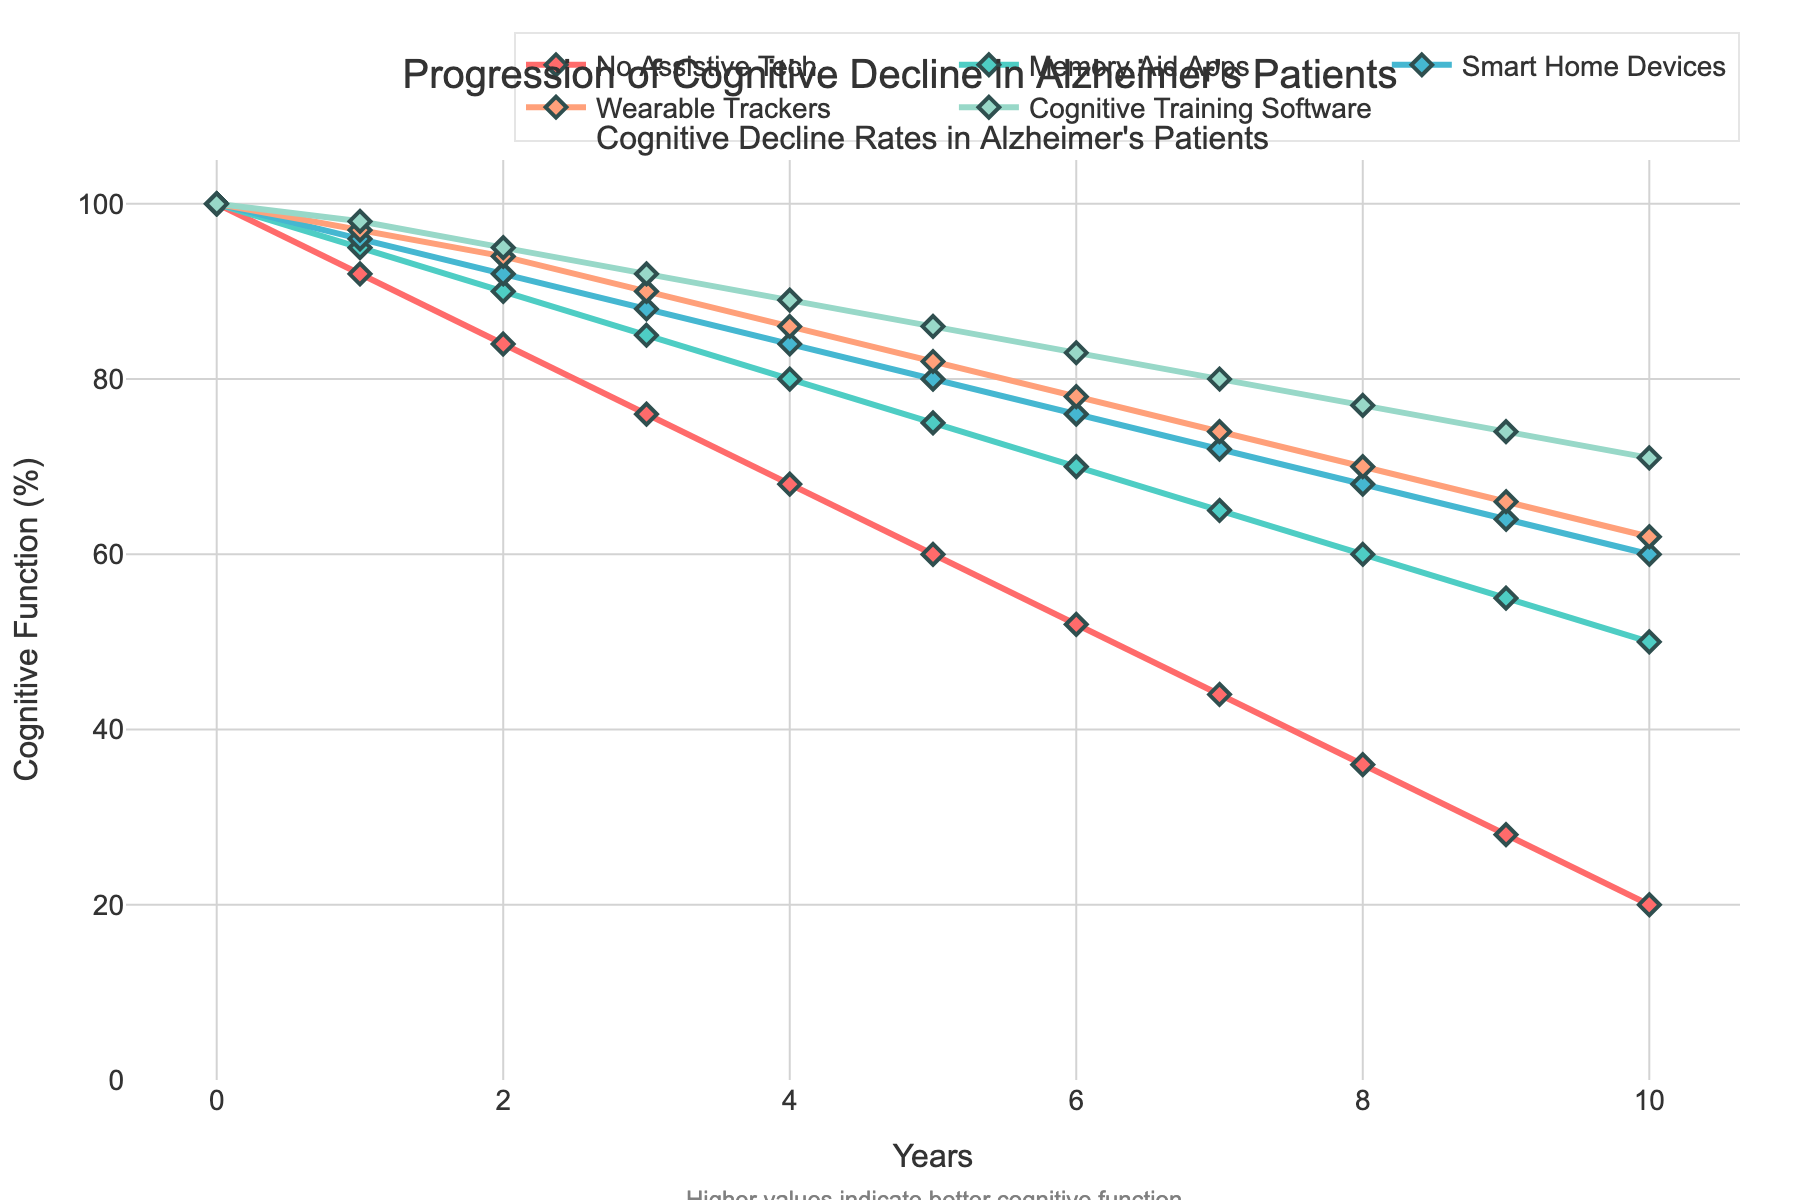What's the trend over the years for patients using no assistive technology? Observing the line for "No Assistive Tech," we see a consistent decline in cognitive function from 100% to 20% over the 10-year period.
Answer: A consistent decline Which assistive technology shows the slowest rate of cognitive decline over 10 years? Compare the endpoints of each technology's line on the y-axis. "Cognitive Training Software" ends at 71%, the highest among all, indicating the slowest cognitive decline.
Answer: Cognitive Training Software How much cognitive function (%) is lost over 10 years using Memory Aid Apps compared to Smart Home Devices? Memory Aid Apps: 100 - 50 = 50%. Smart Home Devices: 100 - 60 = 40%. Difference is 50% - 40% = 10%.
Answer: 10% Which year marks the first time that patients using Memory Aid Apps fall below 75% cognitive function? Examine the "Memory Aid Apps" line and identify the year where the y-value first drops below 75%. This happens at Year 5.
Answer: Year 5 What is the average cognitive function (%) at Year 6 across all technologies? Sum the percentages at Year 6: 52 (No Assistive Tech) + 70 (Memory Aid Apps) + 76 (Smart Home Devices) + 78 (Wearable Trackers) + 83 (Cognitive Training Software) = 359. Then divide by 5 (number of technologies). 359 / 5 = 71.8%
Answer: 71.8% At which year do Wearable Trackers and Smart Home Devices first show the same level of cognitive function? Track their lines on the graph, they first intersect around Year 8 at approximately 70%.
Answer: Year 8 Compare the rate of decline between the first 5 years and the last 5 years for Cognitive Training Software. First 5 years: 100 - 86 = 14% decline. Last 5 years: 86 - 71 = 15% decline.
Answer: Faster decline in the last 5 years Which technology comes closest to maintaining 80% cognitive function by Year 10? Look at Year 10 values: Memory Aid Apps (50%), Smart Home Devices (60%), Wearable Trackers (62%), Cognitive Training Software (71%). Cognitive Training Software is closest.
Answer: Cognitive Training Software What is the percentage difference in cognitive function between "No Assistive Tech" and "Cognitive Training Software" at Year 4? "No Assistive Tech" at Year 4 is 68%. "Cognitive Training Software" is 89%. Difference: 89% - 68% = 21%.
Answer: 21% 